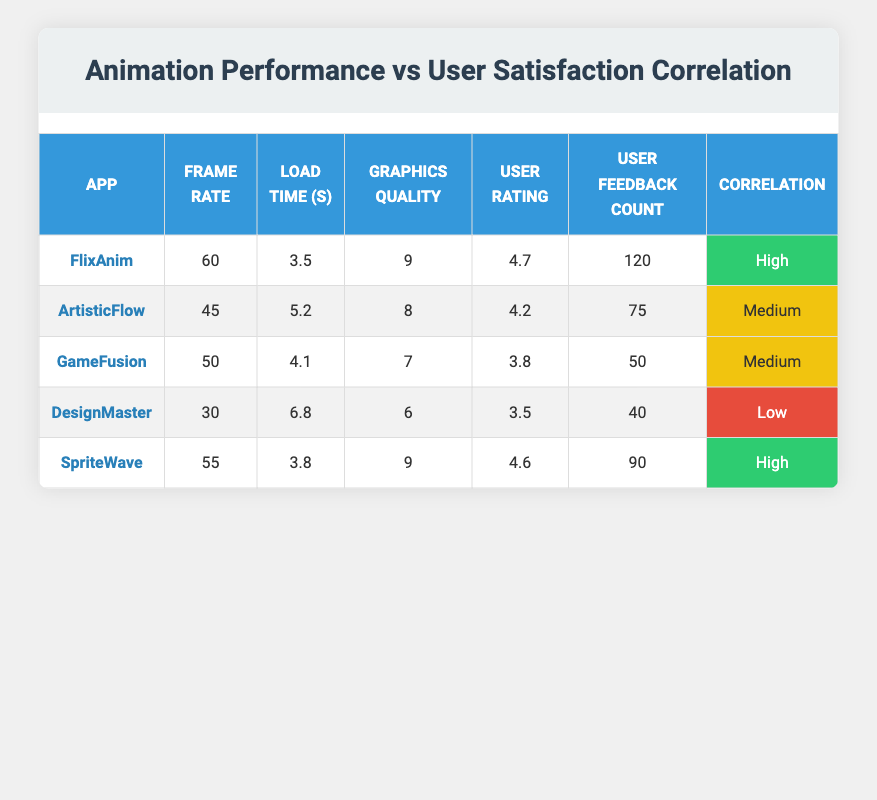What is the frame rate of the app "DesignMaster"? The table lists "DesignMaster" under the App column, and the corresponding Frame Rate is shown in the same row, which is 30.
Answer: 30 Which app has the highest user rating? By comparing the User Rating column, "FlixAnim" has the highest value of 4.7, which is more than any other app listed.
Answer: FlixAnim What is the average load time of the apps with high correlation? Filtering the correlation results, we found "FlixAnim" and "SpriteWave" with load times of 3.5 and 3.8 respectively. Average load time = (3.5 + 3.8) / 2 = 3.65.
Answer: 3.65 Is the load time of "SpriteWave" shorter than that of "ArtisticFlow"? Comparing the Load Time for both apps, "SpriteWave" has a load time of 3.8 seconds while "ArtisticFlow" has 5.2 seconds. Since 3.8 is less than 5.2, the statement is true.
Answer: Yes How much higher is the user rating of "FlixAnim" compared to "DesignMaster"? The user rating for "FlixAnim" is 4.7 and for "DesignMaster" it is 3.5. The difference is 4.7 - 3.5 = 1.2, indicating that "FlixAnim" has a higher user rating by 1.2 points.
Answer: 1.2 